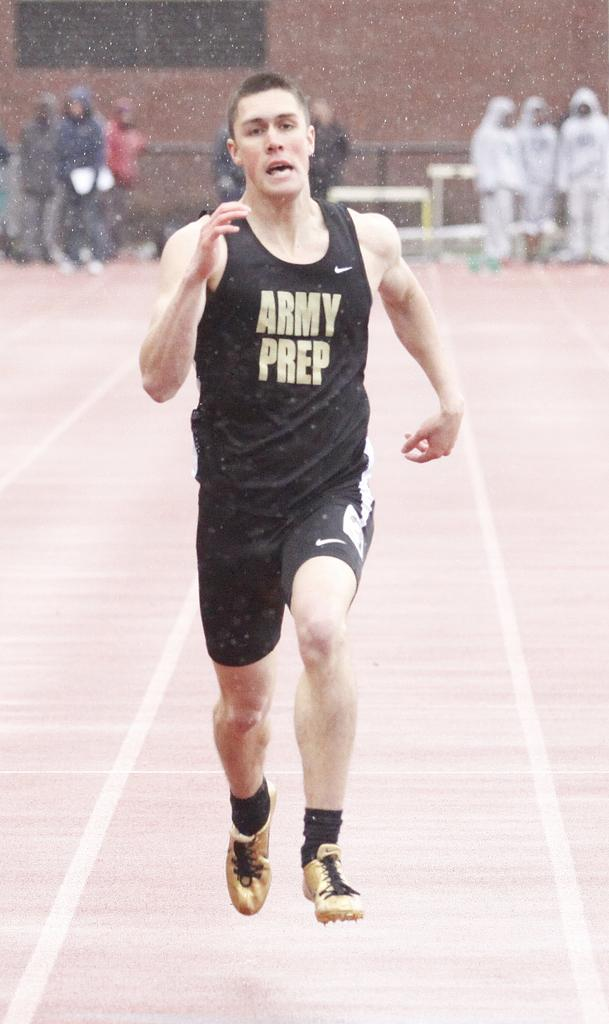Who is present in the image? There is a person in the image. What is the person wearing? The person is wearing a black dress. What is the person doing in the image? The person is running. Can you describe the surroundings in the image? There are other persons in the background of the image. What is the plot of the story unfolding in the image? There is no story or plot depicted in the image; it simply shows a person running while wearing a black dress. How does the frog contribute to the scene in the image? There is no frog present in the image. 